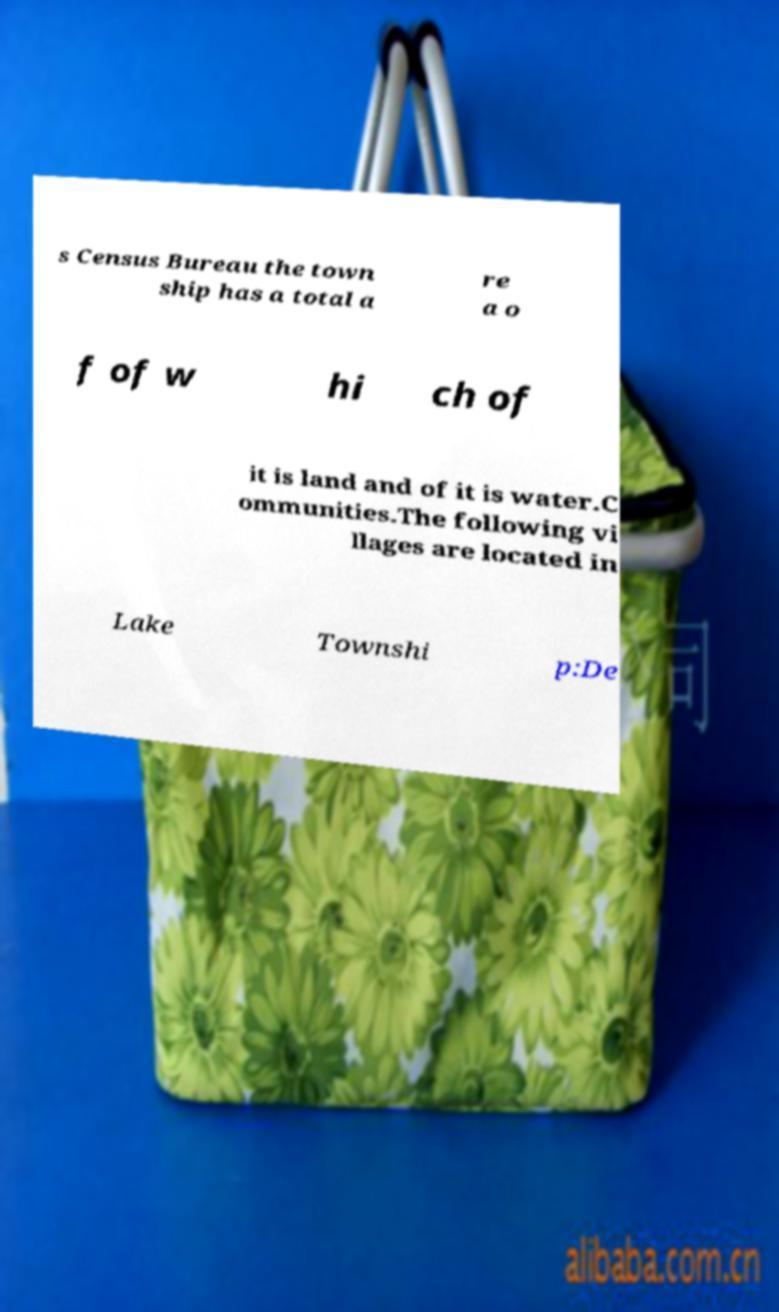Please read and relay the text visible in this image. What does it say? s Census Bureau the town ship has a total a re a o f of w hi ch of it is land and of it is water.C ommunities.The following vi llages are located in Lake Townshi p:De 